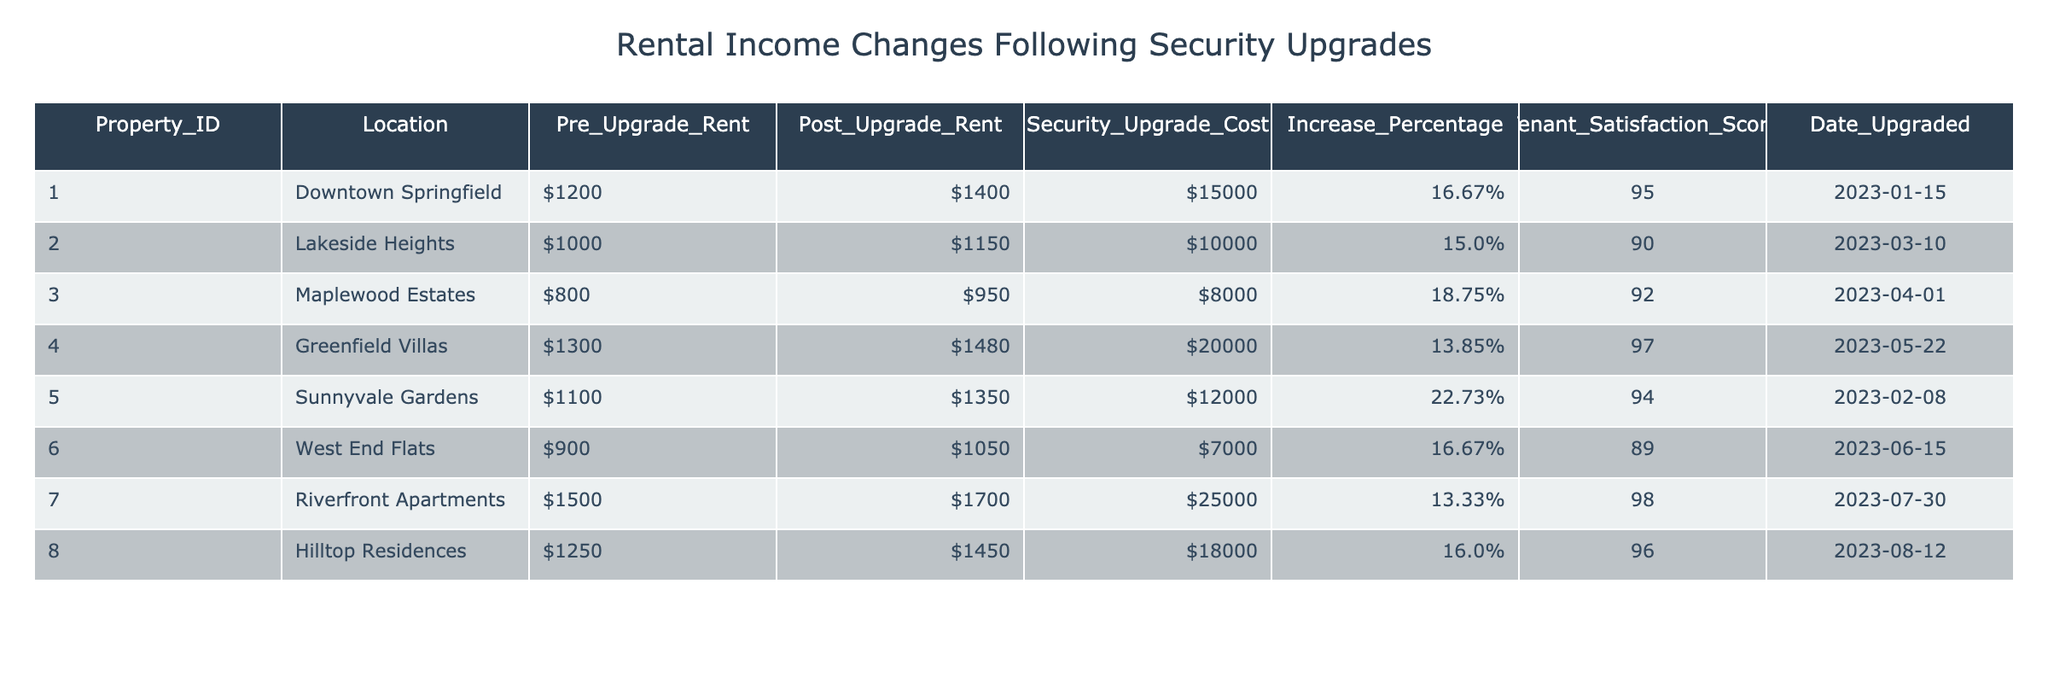What is the increase percentage in rent for the property located in Lakeside Heights? The increase percentage for Lakeside Heights is directly noted in the table under the "Increase_Percentage" column. For property ID 2, the value is 15.00%.
Answer: 15.00% Which property had the highest tenant satisfaction score after the upgrade? To find this, examine the "Tenant_Satisfaction_Score" column and identify which number is the largest. The highest score is 98 for the property "Riverfront Apartments" (Property ID 7).
Answer: Riverfront Apartments What is the total cost of security upgrades for all properties listed in the table? To get the total cost, sum the "Security_Upgrade_Cost" values. Calculating gives $15,000 + $10,000 + $8,000 + $20,000 + $12,000 + $7,000 + $25,000 + $18,000 = $120,000.
Answer: $120,000 Is it true that all properties experienced an increase in rent following the upgrades? By looking at the "Pre_Upgrade_Rent" and "Post_Upgrade_Rent" columns, we can see that each post-upgrade rent value is higher than its corresponding pre-upgrade rent value, confirming that all properties increased rent after the upgrades.
Answer: Yes What is the average percentage increase in rent across all properties after security upgrades? First, we find the sum of the "Increase_Percentage" values: 16.67 + 15.00 + 18.75 + 13.85 + 22.73 + 16.67 + 13.33 + 16.00 = 132.00. There are 8 properties, so the average is 132.00 / 8 = 16.50%.
Answer: 16.50% Which property had the lowest pre-upgrade rent and what was the security upgrade cost for that property? The lowest pre-upgrade rent is noted in the table for "Maplewood Estates" with a rent of $800, and the corresponding security upgrade cost is $8,000.
Answer: Maplewood Estates, $8,000 How many properties had a tenant satisfaction score greater than 95 after the security upgrades? By filtering the "Tenant_Satisfaction_Score" column for scores greater than 95, we find the properties: "Greenfield Villas" (97), "Riverfront Apartments" (98), and "Hilltop Residences" (96), totaling three properties.
Answer: 3 What is the difference in post-upgrade rent between Downtown Springfield and Sunnyvale Gardens? The post-upgrade rent for Downtown Springfield is $1,400 and for Sunnyvale Gardens is $1,350. The difference is $1,400 - $1,350 = $50.
Answer: $50 